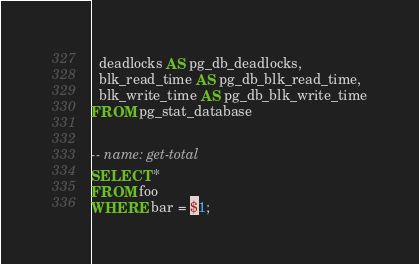<code> <loc_0><loc_0><loc_500><loc_500><_SQL_>  deadlocks AS pg_db_deadlocks,
  blk_read_time AS pg_db_blk_read_time,
  blk_write_time AS pg_db_blk_write_time
FROM pg_stat_database


-- name: get-total
SELECT *
FROM foo
WHERE bar = $1;
</code> 